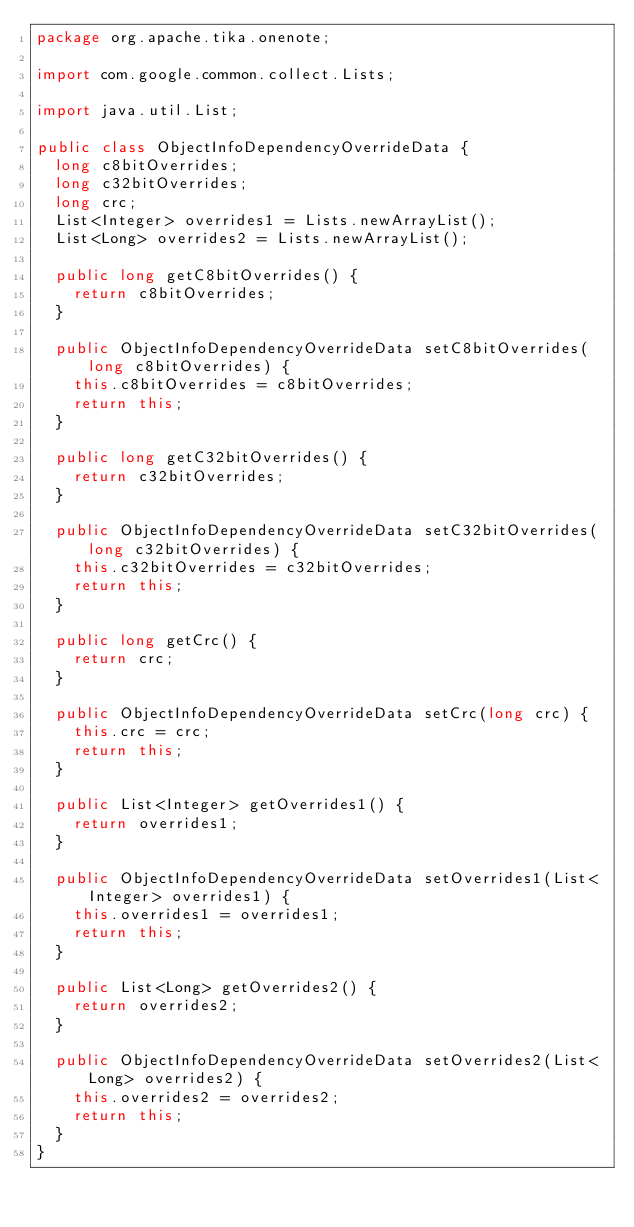Convert code to text. <code><loc_0><loc_0><loc_500><loc_500><_Java_>package org.apache.tika.onenote;

import com.google.common.collect.Lists;

import java.util.List;

public class ObjectInfoDependencyOverrideData {
  long c8bitOverrides;
  long c32bitOverrides;
  long crc;
  List<Integer> overrides1 = Lists.newArrayList();
  List<Long> overrides2 = Lists.newArrayList();

  public long getC8bitOverrides() {
    return c8bitOverrides;
  }

  public ObjectInfoDependencyOverrideData setC8bitOverrides(long c8bitOverrides) {
    this.c8bitOverrides = c8bitOverrides;
    return this;
  }

  public long getC32bitOverrides() {
    return c32bitOverrides;
  }

  public ObjectInfoDependencyOverrideData setC32bitOverrides(long c32bitOverrides) {
    this.c32bitOverrides = c32bitOverrides;
    return this;
  }

  public long getCrc() {
    return crc;
  }

  public ObjectInfoDependencyOverrideData setCrc(long crc) {
    this.crc = crc;
    return this;
  }

  public List<Integer> getOverrides1() {
    return overrides1;
  }

  public ObjectInfoDependencyOverrideData setOverrides1(List<Integer> overrides1) {
    this.overrides1 = overrides1;
    return this;
  }

  public List<Long> getOverrides2() {
    return overrides2;
  }

  public ObjectInfoDependencyOverrideData setOverrides2(List<Long> overrides2) {
    this.overrides2 = overrides2;
    return this;
  }
}
</code> 